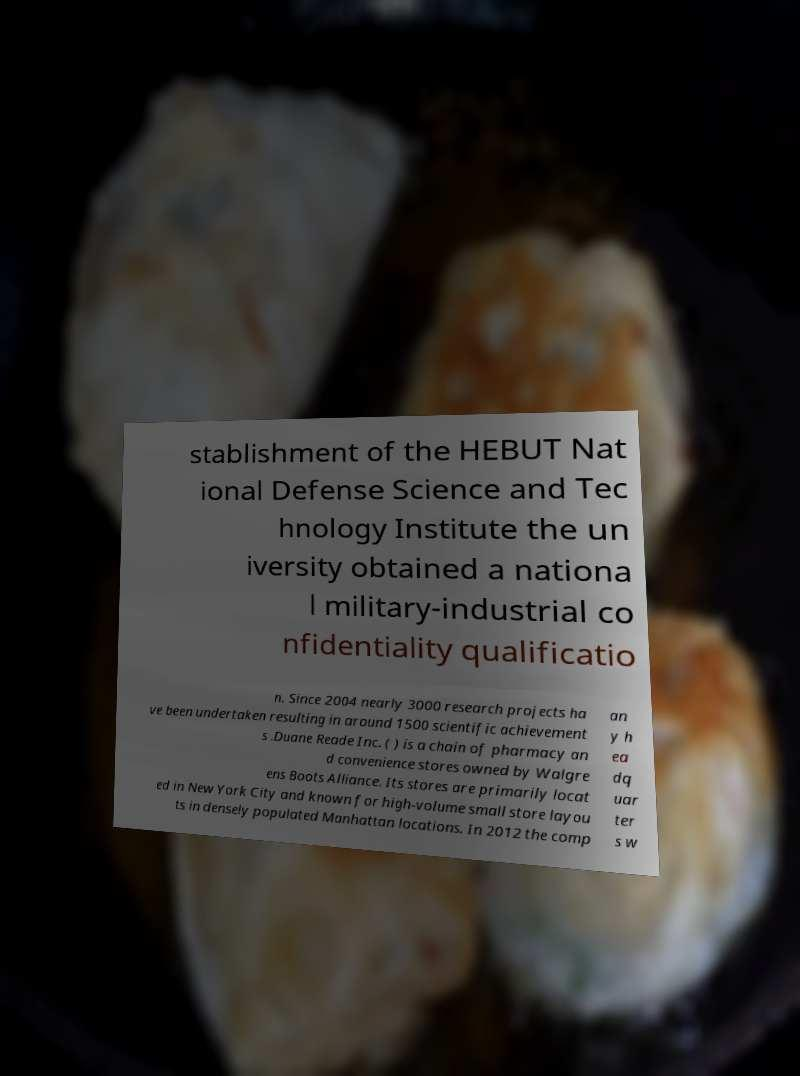What messages or text are displayed in this image? I need them in a readable, typed format. stablishment of the HEBUT Nat ional Defense Science and Tec hnology Institute the un iversity obtained a nationa l military-industrial co nfidentiality qualificatio n. Since 2004 nearly 3000 research projects ha ve been undertaken resulting in around 1500 scientific achievement s .Duane Reade Inc. ( ) is a chain of pharmacy an d convenience stores owned by Walgre ens Boots Alliance. Its stores are primarily locat ed in New York City and known for high-volume small store layou ts in densely populated Manhattan locations. In 2012 the comp an y h ea dq uar ter s w 